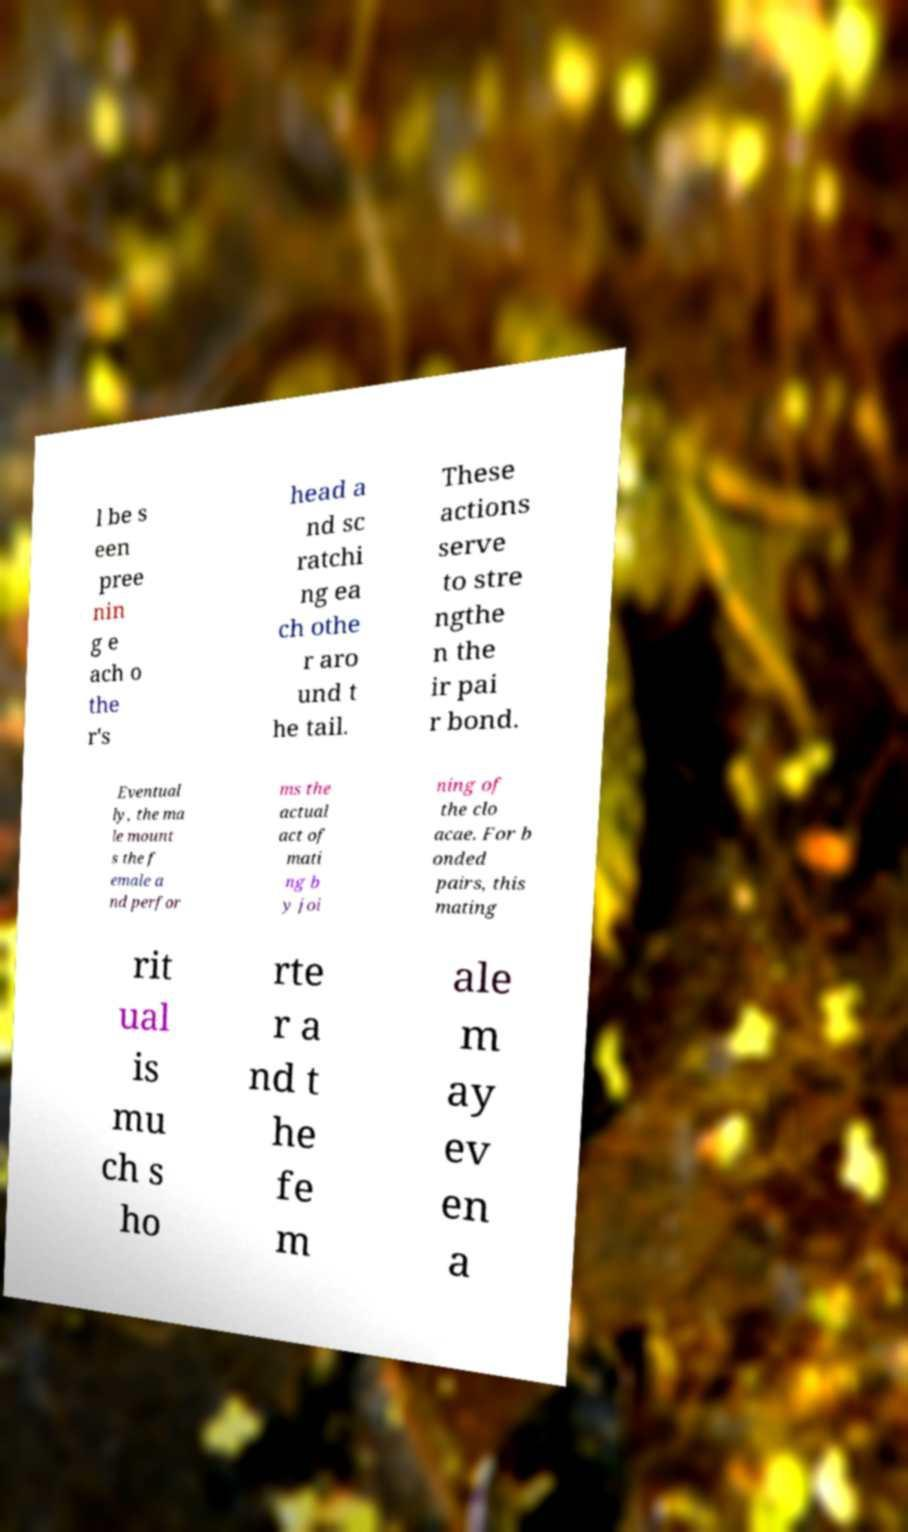What messages or text are displayed in this image? I need them in a readable, typed format. l be s een pree nin g e ach o the r's head a nd sc ratchi ng ea ch othe r aro und t he tail. These actions serve to stre ngthe n the ir pai r bond. Eventual ly, the ma le mount s the f emale a nd perfor ms the actual act of mati ng b y joi ning of the clo acae. For b onded pairs, this mating rit ual is mu ch s ho rte r a nd t he fe m ale m ay ev en a 